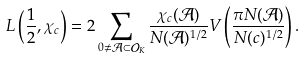Convert formula to latex. <formula><loc_0><loc_0><loc_500><loc_500>L \left ( \frac { 1 } { 2 } , \chi _ { c } \right ) = 2 \sum _ { 0 \neq \mathcal { A } \subset \mathcal { O } _ { K } } \frac { \chi _ { c } ( \mathcal { A } ) } { N ( \mathcal { A } ) ^ { 1 / 2 } } V \left ( \frac { \pi N ( \mathcal { A } ) } { N ( c ) ^ { 1 / 2 } } \right ) .</formula> 